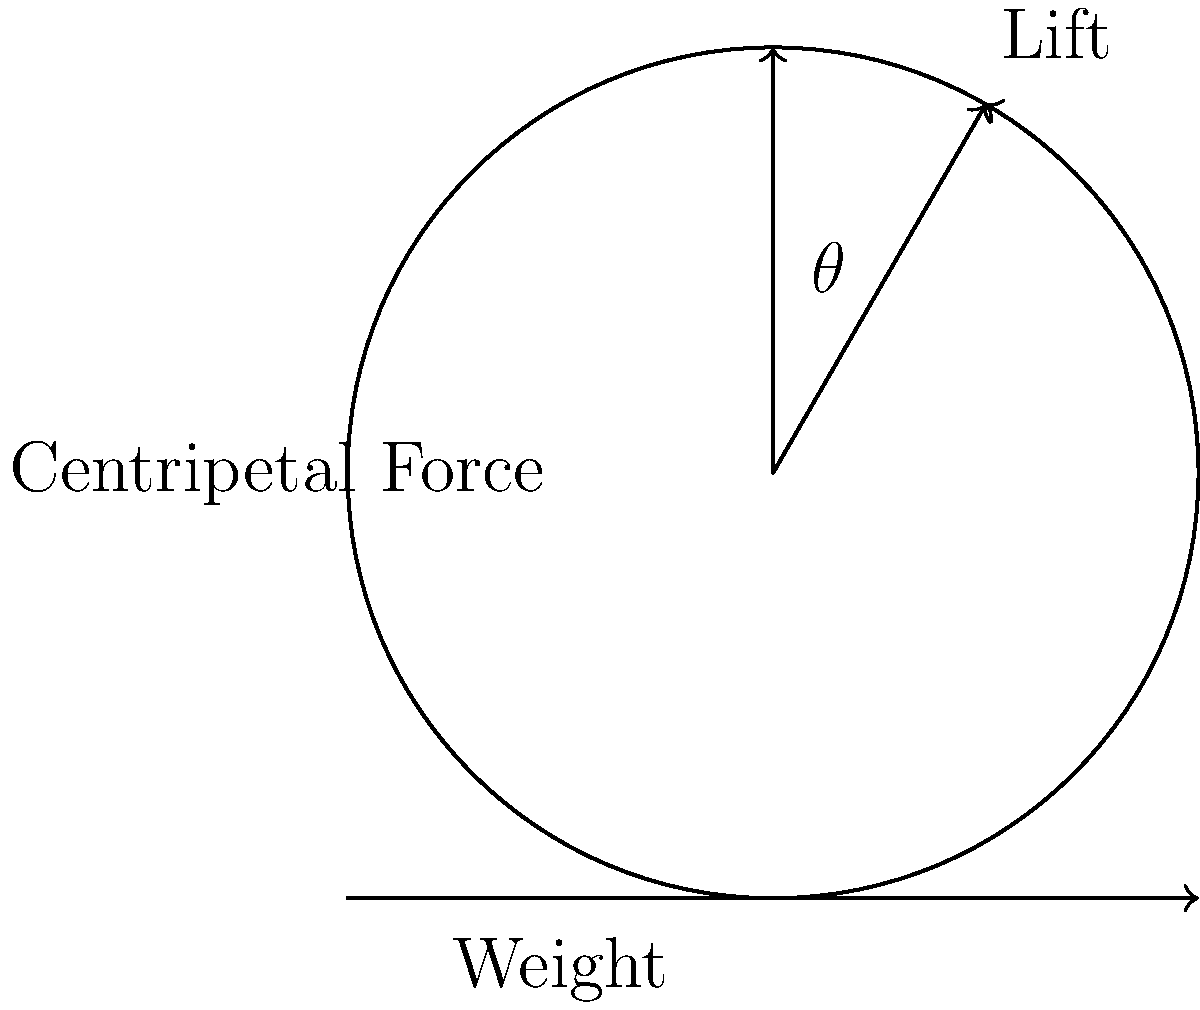As a Thunderbird pilot performing a banking turn at constant altitude, you need to determine the optimal bank angle. Given that the aircraft's weight is 30,000 lbs and it's traveling at 500 mph in a turn with a radius of 2,000 ft, what is the required bank angle $\theta$ to maintain level flight? To solve this problem, we'll follow these steps:

1) In a level banking turn, the vertical component of lift must equal the weight of the aircraft:

   $L \cos \theta = W$

2) The horizontal component of lift provides the centripetal force:

   $L \sin \theta = \frac{mv^2}{r}$

3) Dividing these equations:

   $\tan \theta = \frac{v^2}{rg}$

4) We need to convert our given values to appropriate units:
   - Speed: 500 mph = 733.33 ft/s
   - Radius: 2,000 ft
   - g = 32.2 ft/s²

5) Now we can substitute these values:

   $\tan \theta = \frac{(733.33)^2}{2000 \times 32.2} = 8.3424$

6) To find $\theta$, we take the inverse tangent:

   $\theta = \arctan(8.3424) = 83.17°$

This angle ensures that the vertical component of lift equals the weight, while the horizontal component provides the necessary centripetal force for the turn.
Answer: $83.17°$ 